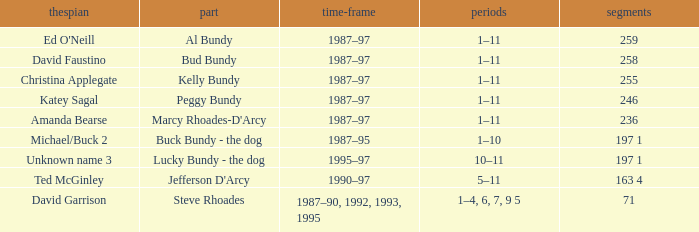How many years did the role of Steve Rhoades last? 1987–90, 1992, 1993, 1995. 